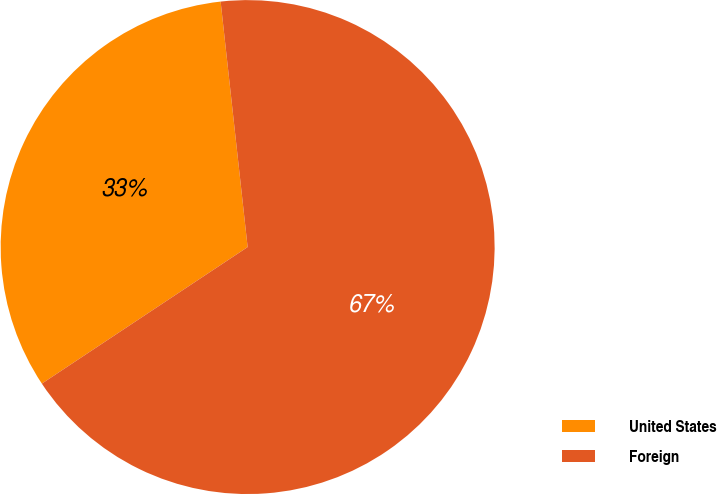<chart> <loc_0><loc_0><loc_500><loc_500><pie_chart><fcel>United States<fcel>Foreign<nl><fcel>32.58%<fcel>67.42%<nl></chart> 